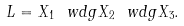<formula> <loc_0><loc_0><loc_500><loc_500>L = X _ { 1 } \ w d g X _ { 2 } \ w d g X _ { 3 } .</formula> 